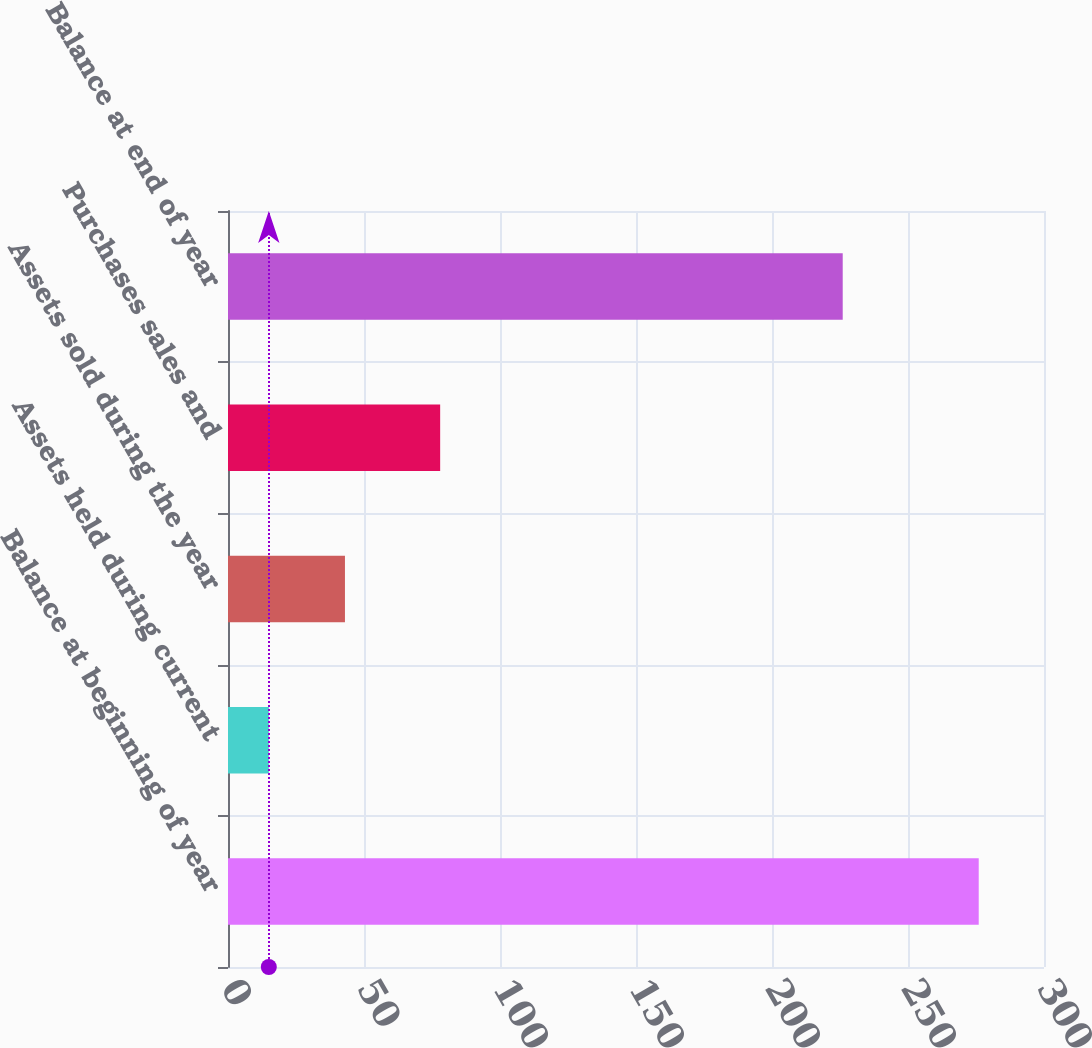Convert chart. <chart><loc_0><loc_0><loc_500><loc_500><bar_chart><fcel>Balance at beginning of year<fcel>Assets held during current<fcel>Assets sold during the year<fcel>Purchases sales and<fcel>Balance at end of year<nl><fcel>276<fcel>15<fcel>43<fcel>78<fcel>226<nl></chart> 